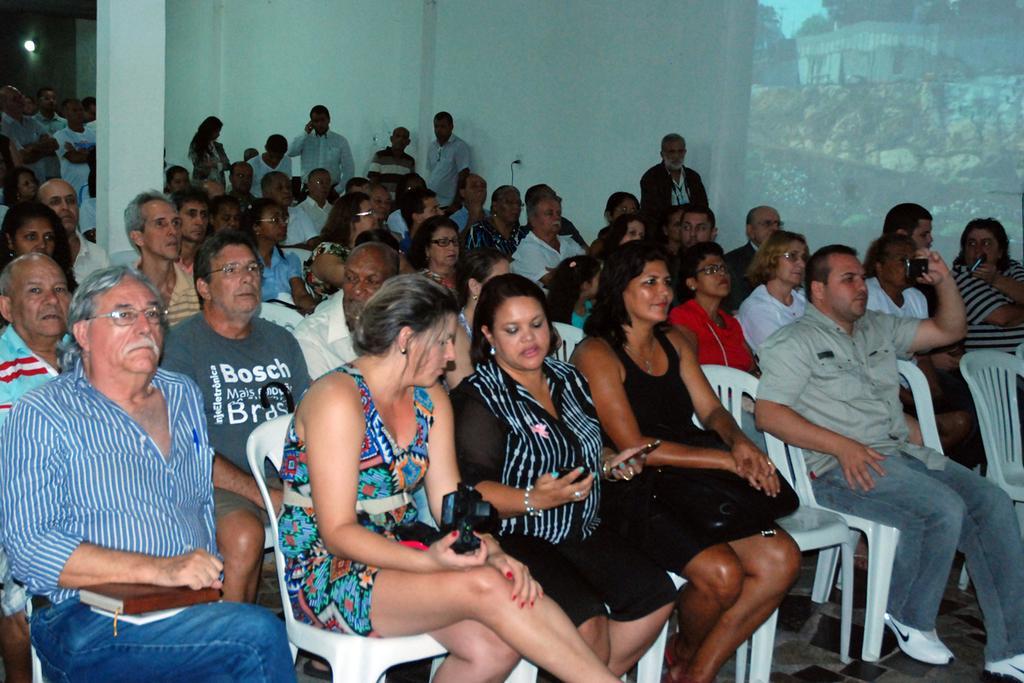Describe this image in one or two sentences. In this aimeg, we can see a group of people. Few people are sitting on the chairs. Few people are holding some objects. Background we can see walls, screen, pillars, light, wires and few people are standing. Here we can see sockets on the wall. 